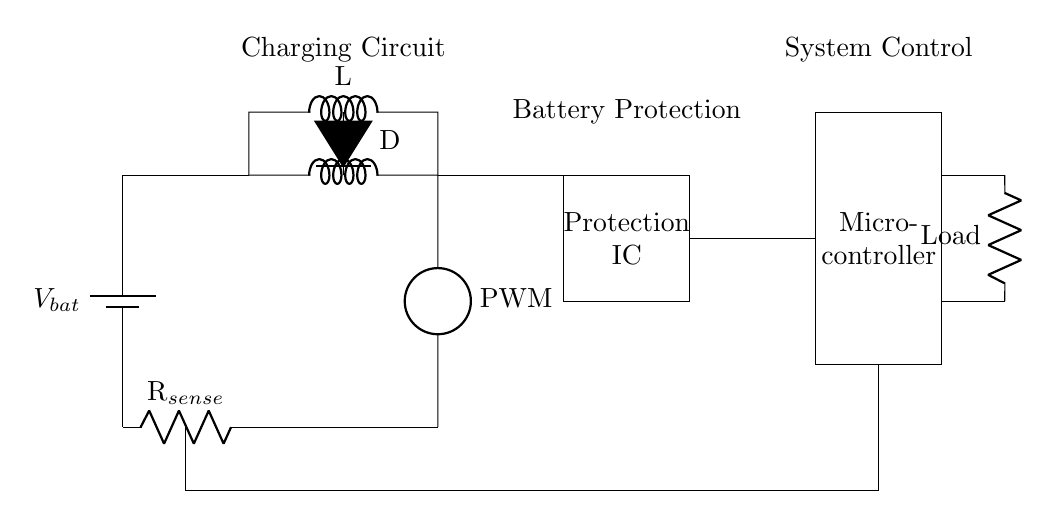What is the role of the inductor in this circuit? The inductor is part of the charging circuit and is responsible for smoothing out current flow and preventing sudden changes in current. It helps in storing energy during the charging phase.
Answer: Charging circuit What component is used for current sensing? The current sensing is performed by a resistor labeled as R, which measures the current passing through it by producing a voltage drop proportional to the current.
Answer: R How many components are involved in the protection circuit section? There are two components: a protection Integrated Circuit (IC) and a diode. The IC manages and protects the battery from overcharging and discharge conditions.
Answer: Two What does PWM stand for in this circuit? PWM stands for Pulse Width Modulation. It is used to control the power delivered to the load and modulate the voltage by varying the width of the pulses, which is vital for efficient battery management.
Answer: Pulse Width Modulation Which component manages the overall system? The microcontroller manages the overall system by processing data from the current sense resistor and ensuring safe operation of the battery management system, including controlling charging and discharging.
Answer: Microcontroller What could happen if the protection circuit fails? If the protection circuit fails, the battery may overcharge or discharge excessively, leading to potential battery damage, reduced lifespan, or even safety hazards such as overheating or fire.
Answer: Overcharging 